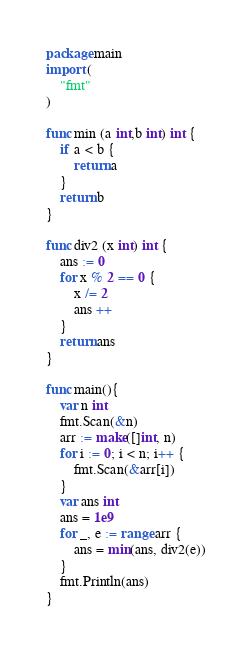<code> <loc_0><loc_0><loc_500><loc_500><_Go_>package main
import (
    "fmt"
)

func min (a int,b int) int {
    if a < b {
        return a
    }
    return b
}

func div2 (x int) int {
    ans := 0
    for x % 2 == 0 {
        x /= 2
        ans ++
    }
    return ans
}

func main(){
    var n int
    fmt.Scan(&n)
    arr := make([]int, n)
    for i := 0; i < n; i++ {
        fmt.Scan(&arr[i])
    }
    var ans int
    ans = 1e9
    for _, e := range arr {
        ans = min(ans, div2(e))
    }
    fmt.Println(ans)
}</code> 